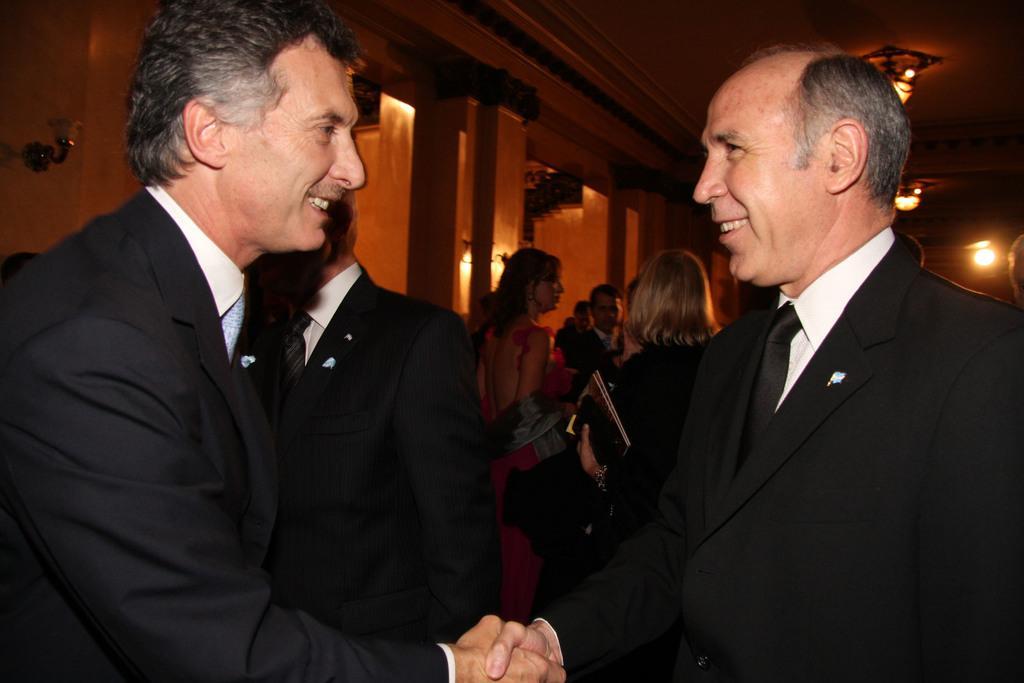In one or two sentences, can you explain what this image depicts? In this image we can see a group of people standing. One woman is holding books and some objects in her hand. In the background, we can see group of lights and some pillars. 